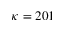Convert formula to latex. <formula><loc_0><loc_0><loc_500><loc_500>\kappa = 2 0 1</formula> 